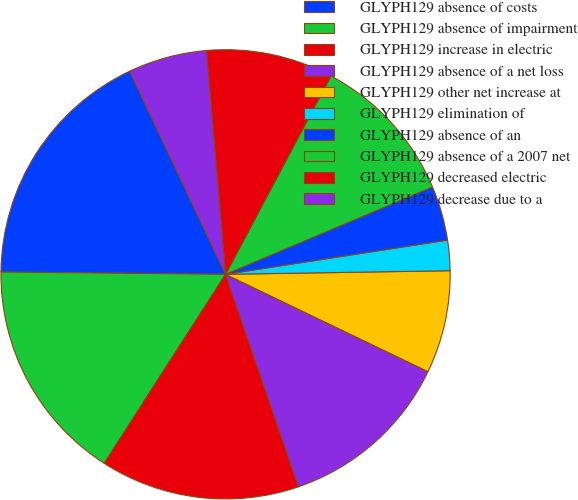Convert chart. <chart><loc_0><loc_0><loc_500><loc_500><pie_chart><fcel>GLYPH129 absence of costs<fcel>GLYPH129 absence of impairment<fcel>GLYPH129 increase in electric<fcel>GLYPH129 absence of a net loss<fcel>GLYPH129 other net increase at<fcel>GLYPH129 elimination of<fcel>GLYPH129 absence of an<fcel>GLYPH129 absence of a 2007 net<fcel>GLYPH129 decreased electric<fcel>GLYPH129 decrease due to a<nl><fcel>17.82%<fcel>16.08%<fcel>14.34%<fcel>12.61%<fcel>7.39%<fcel>2.18%<fcel>3.92%<fcel>10.87%<fcel>9.13%<fcel>5.66%<nl></chart> 